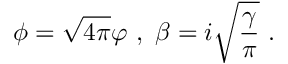<formula> <loc_0><loc_0><loc_500><loc_500>\phi = \sqrt { 4 \pi } \varphi \ , \ \beta = i \sqrt { \frac { \gamma } { \pi } } \ .</formula> 